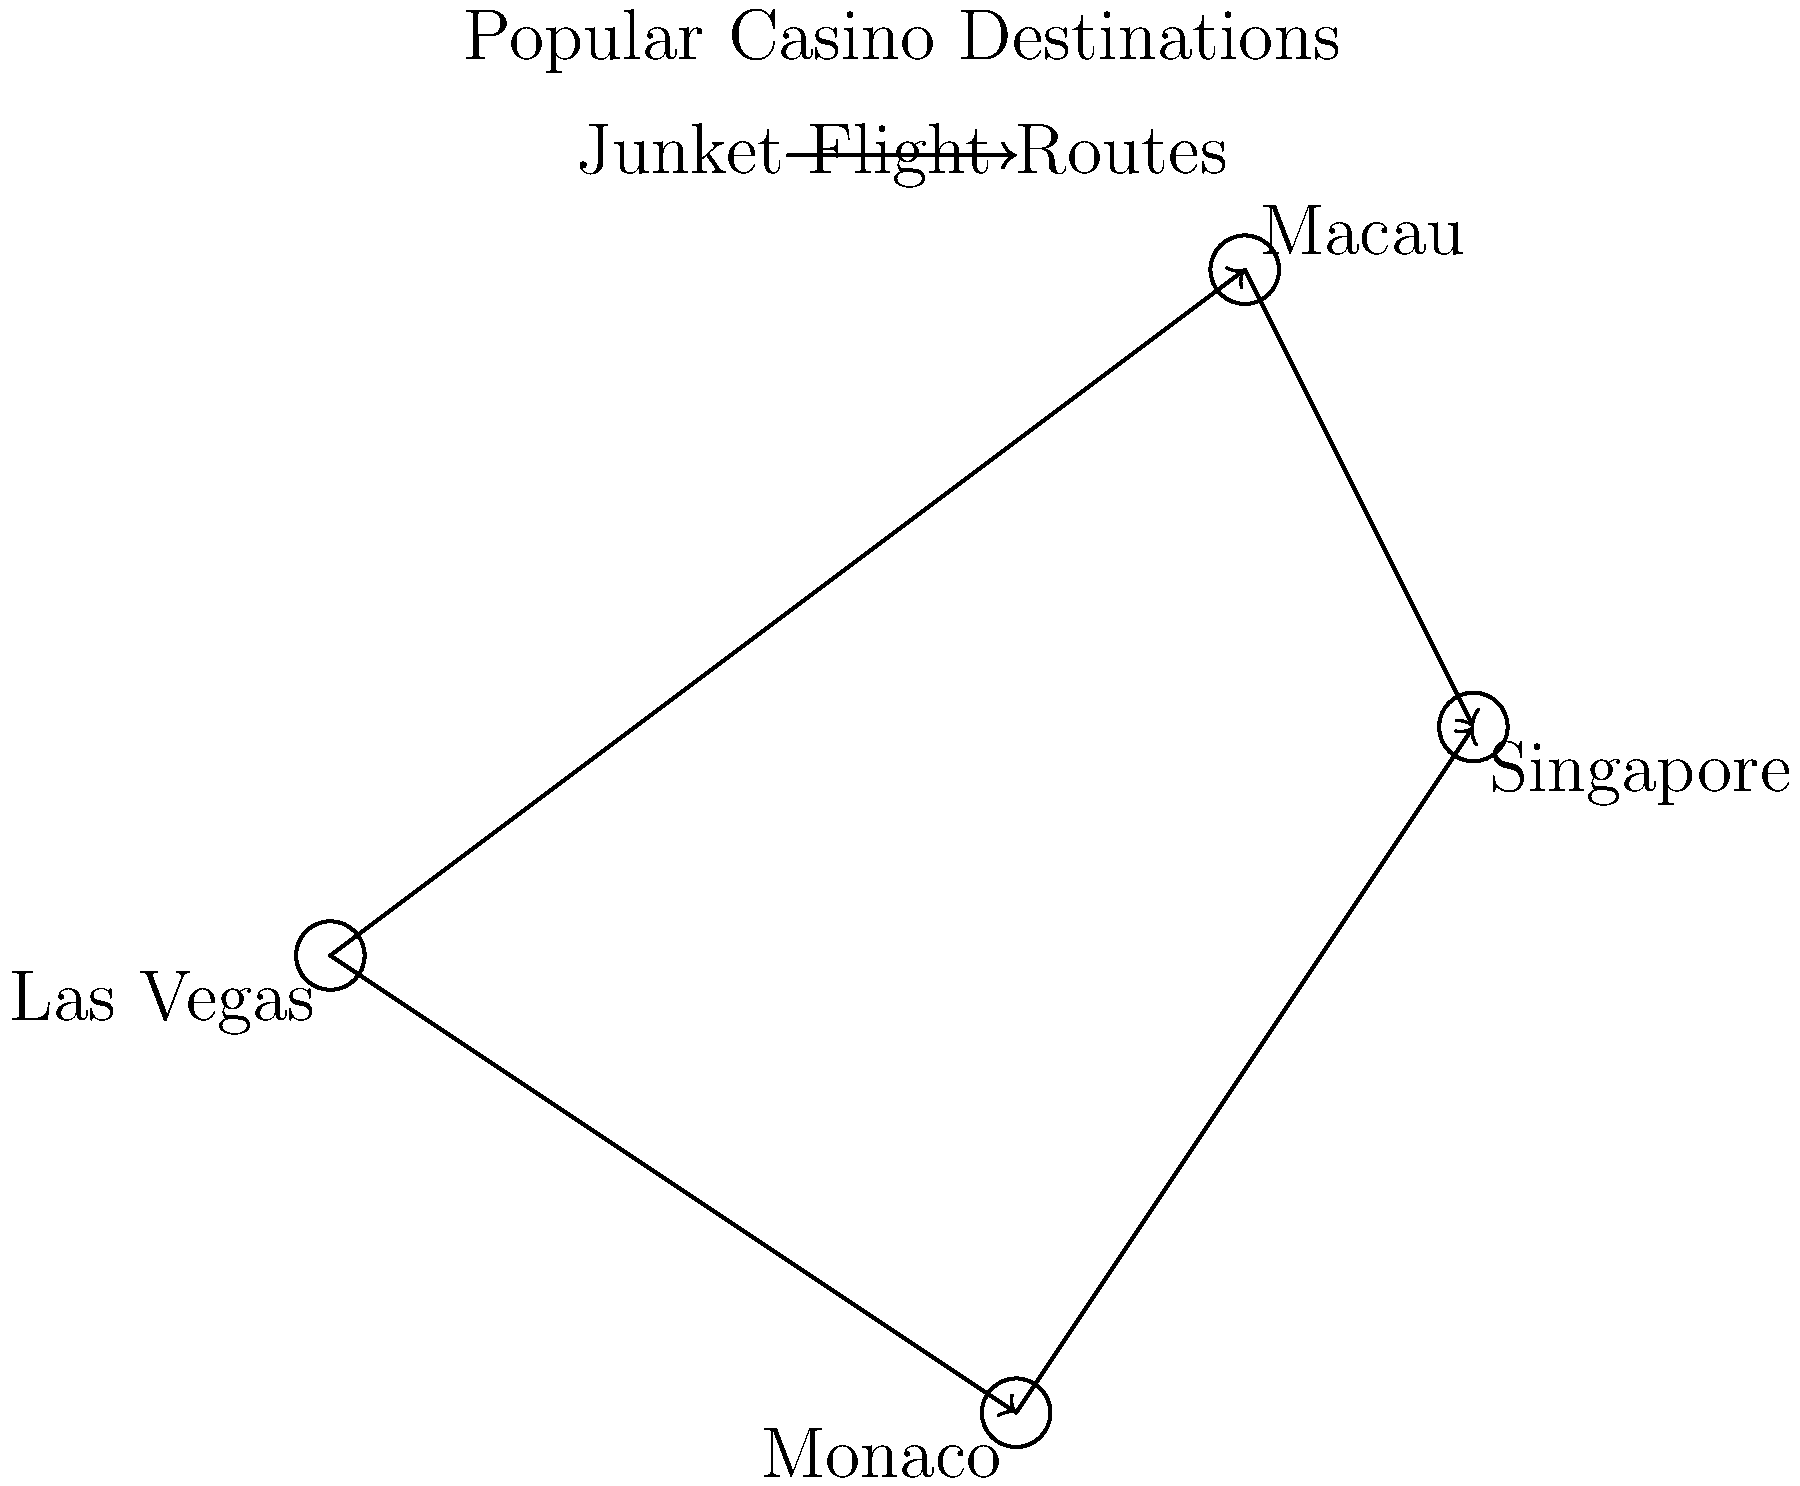Based on the map of popular casino destinations and their junket flight routes, which city appears to be the most central hub for casino junkets, connecting to the highest number of other destinations? To determine the most central hub for casino junkets, we need to analyze the flight routes shown on the map:

1. Las Vegas:
   - Has direct routes to Macau and Monaco
   - Connected to 2 other destinations

2. Macau:
   - Has direct routes to Las Vegas and Singapore
   - Connected to 2 other destinations

3. Monaco:
   - Has direct routes to Las Vegas and Singapore
   - Connected to 2 other destinations

4. Singapore:
   - Has direct routes to Macau and Monaco
   - Connected to 2 other destinations

After analyzing the connections, we can see that all four cities are connected to two other destinations. However, Las Vegas stands out as it is the only city that has direct routes to both European (Monaco) and Asian (Macau) destinations, making it a bridge between these regions.

Given its strategic position connecting different continents and its equal number of connections compared to other cities, Las Vegas appears to be the most central hub for casino junkets in this network.
Answer: Las Vegas 